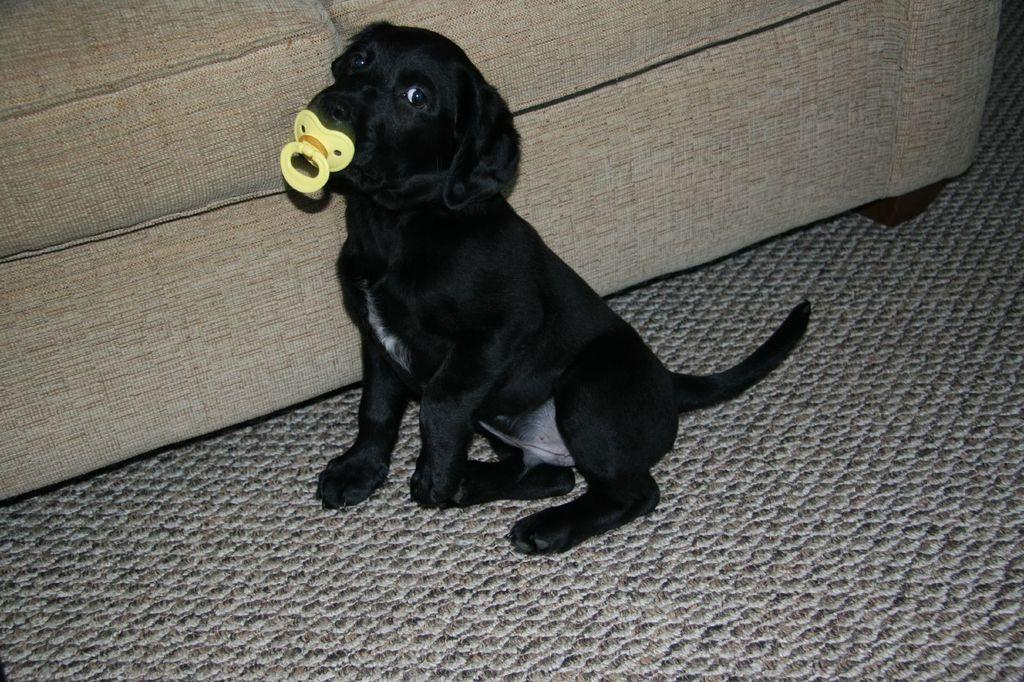What type of animal is on the floor in the image? There is a dog on the floor in the image. What type of furniture can be seen in the background of the image? There is a sofa in the background of the image. What type of education does the dog have in the image? There is no indication of the dog's education in the image. What type of waves can be seen in the image? There are no waves present in the image. 